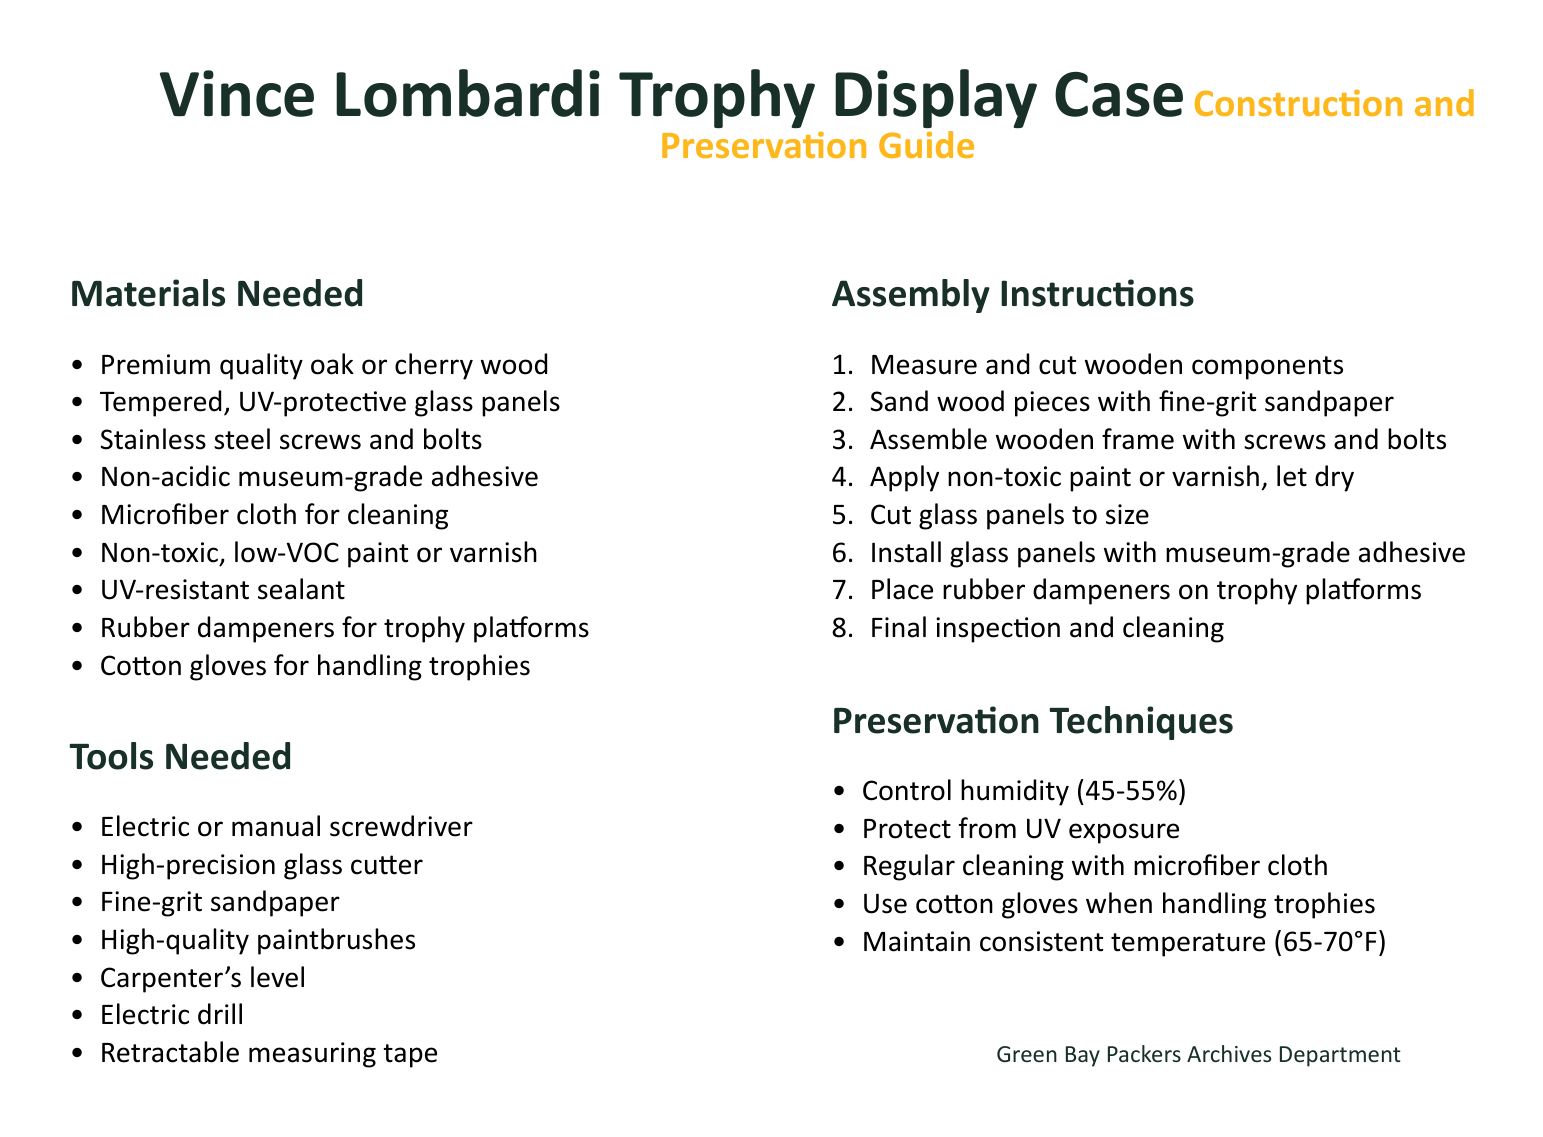what type of wood is recommended for the display case? The document specifies "premium quality oak or cherry wood" as the recommended types of wood.
Answer: oak or cherry what tools are needed for cutting glass? The document lists "high-precision glass cutter" as a specific tool required for cutting glass.
Answer: high-precision glass cutter how many components are mentioned in the assembly instructions? The assembly instructions consist of eight enumerated steps detailing the construction process.
Answer: 8 what is the recommended temperature range for preservation? The document states that the ideal temperature for preservation should be maintained between 65 to 70 degrees Fahrenheit.
Answer: 65-70°F what type of adhesive is suggested for installing glass panels? The instructions recommend using "non-acidic museum-grade adhesive" for attaching glass panels.
Answer: non-acidic museum-grade adhesive why should rubber dampeners be used? The document notes that rubber dampeners are placed on trophy platforms to provide cushioning and protect the trophies.
Answer: protection what is one cleaning tool recommended for maintenance? The document mentions using a "microfiber cloth" for regular cleaning of the display case.
Answer: microfiber cloth which type of paint is suggested for finishing the wood? The document advises using "non-toxic, low-VOC paint or varnish" for finishing the wooden components.
Answer: non-toxic, low-VOC paint or varnish how should humidity be controlled for preservation? The document recommends maintaining humidity levels between 45 to 55 percent for optimal preservation.
Answer: 45-55% 